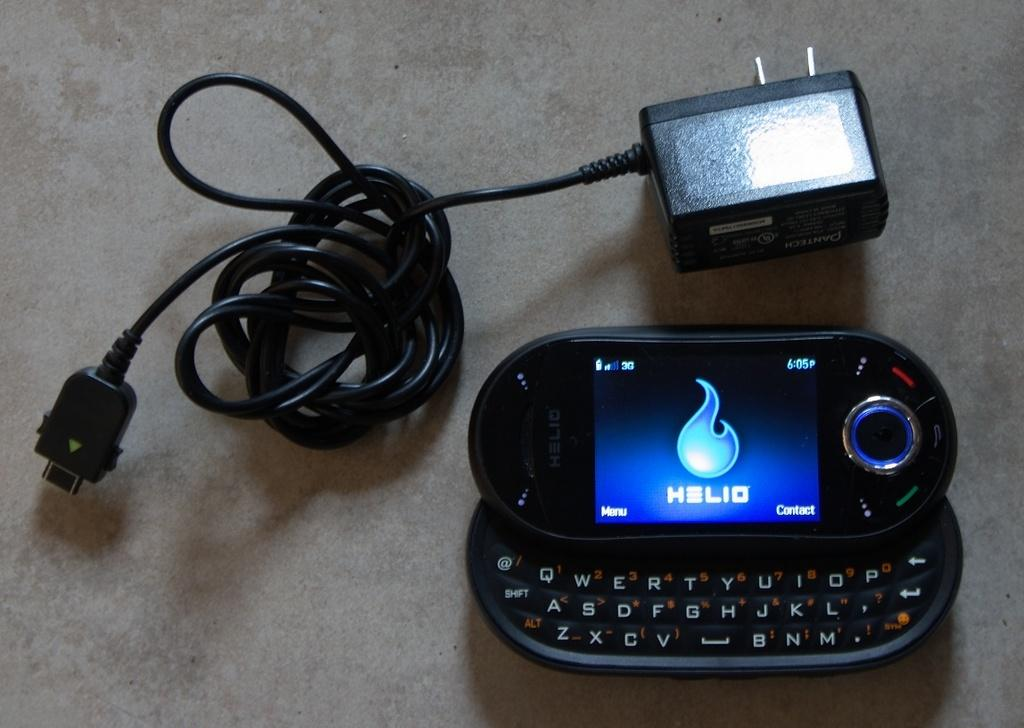<image>
Offer a succinct explanation of the picture presented. a cellphone open to a screen reading HELIO next to a charger 